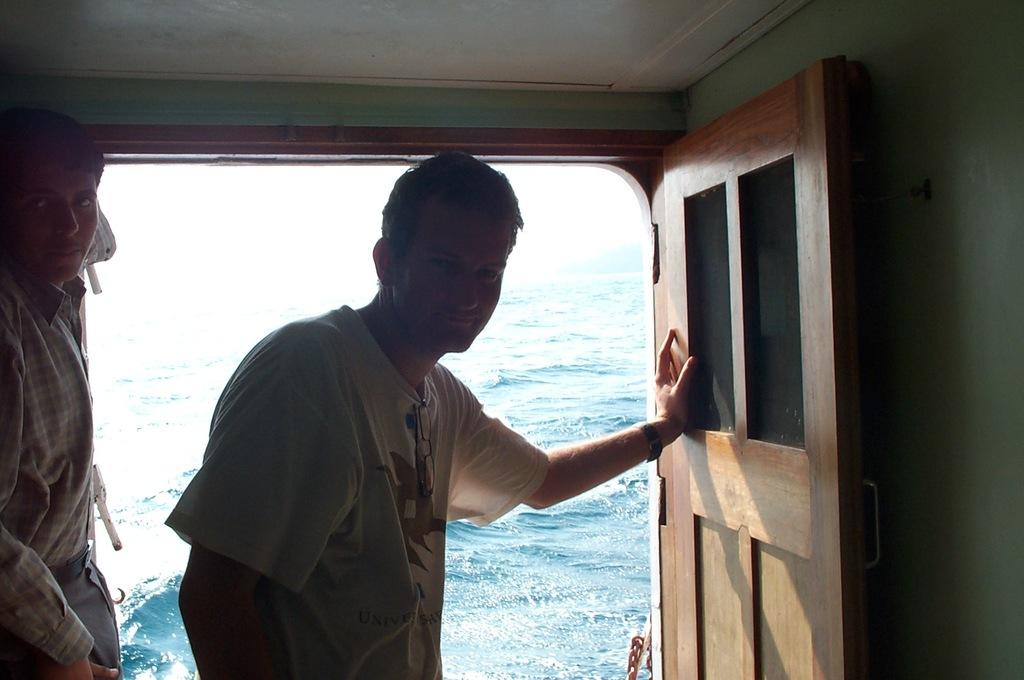What is the main subject of the image? The image appears to depict a ship. Are there any people visible in the image? Yes, there are two people standing inside the ship. What feature of the ship can be seen in the image? There is a door visible in the ship. What is visible in the background of the image? Water is present in the background of the image. What type of treatment is being administered to the screw in the image? There is no screw present in the image, and therefore no treatment can be observed. 